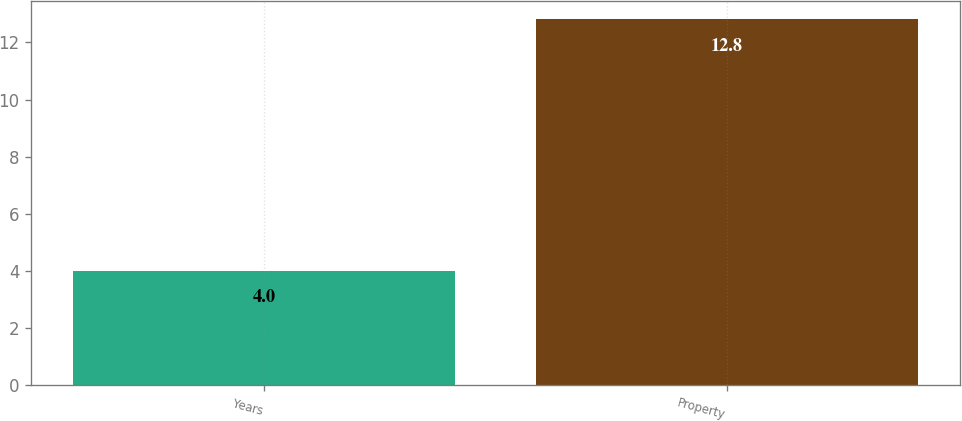Convert chart. <chart><loc_0><loc_0><loc_500><loc_500><bar_chart><fcel>Years<fcel>Property<nl><fcel>4<fcel>12.8<nl></chart> 